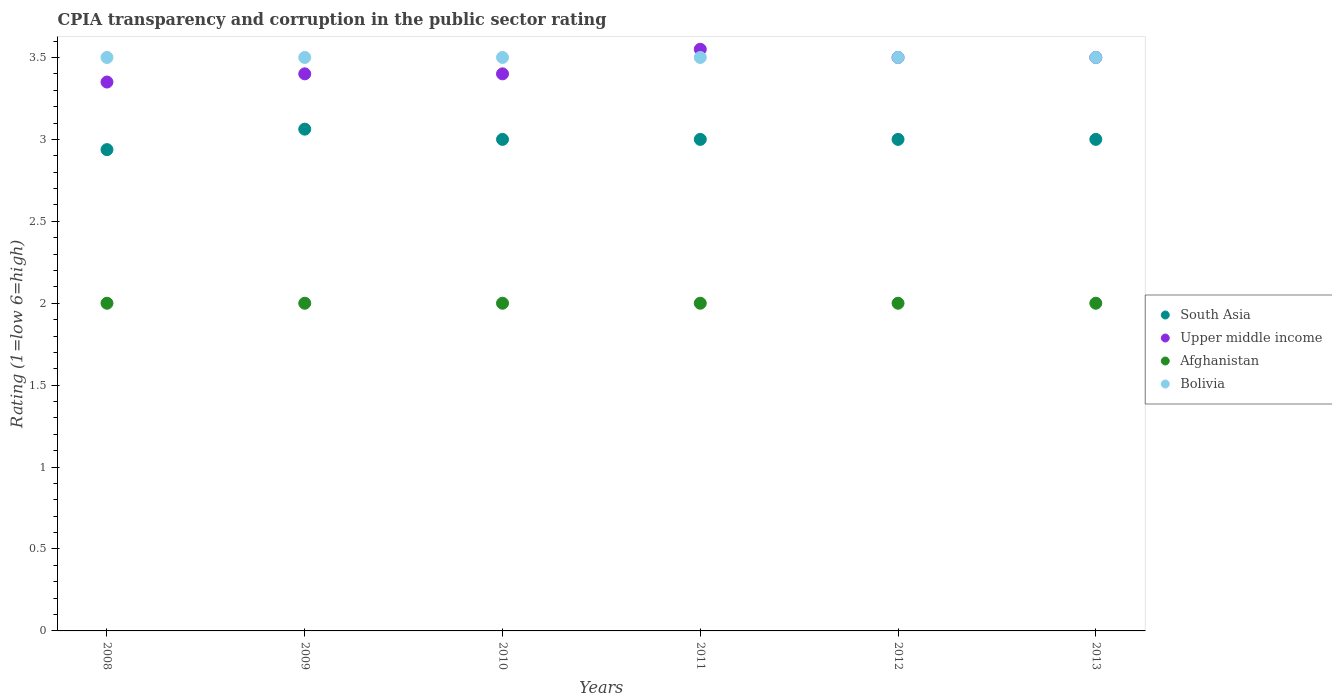How many different coloured dotlines are there?
Offer a very short reply. 4. What is the CPIA rating in South Asia in 2008?
Provide a short and direct response. 2.94. In which year was the CPIA rating in Afghanistan minimum?
Your answer should be very brief. 2008. What is the total CPIA rating in South Asia in the graph?
Provide a short and direct response. 18. What is the difference between the CPIA rating in South Asia in 2009 and that in 2011?
Your answer should be very brief. 0.06. What is the average CPIA rating in Afghanistan per year?
Provide a short and direct response. 2. In the year 2013, what is the difference between the CPIA rating in Afghanistan and CPIA rating in Upper middle income?
Your answer should be very brief. -1.5. In how many years, is the CPIA rating in Bolivia greater than 1.7?
Make the answer very short. 6. What is the ratio of the CPIA rating in South Asia in 2009 to that in 2011?
Make the answer very short. 1.02. Is the CPIA rating in Upper middle income in 2011 less than that in 2012?
Make the answer very short. No. What is the difference between the highest and the second highest CPIA rating in South Asia?
Ensure brevity in your answer.  0.06. In how many years, is the CPIA rating in Afghanistan greater than the average CPIA rating in Afghanistan taken over all years?
Your answer should be compact. 0. Does the CPIA rating in Bolivia monotonically increase over the years?
Offer a very short reply. No. Is the CPIA rating in South Asia strictly less than the CPIA rating in Bolivia over the years?
Give a very brief answer. Yes. What is the difference between two consecutive major ticks on the Y-axis?
Make the answer very short. 0.5. Does the graph contain grids?
Your answer should be very brief. No. How many legend labels are there?
Your answer should be very brief. 4. How are the legend labels stacked?
Provide a succinct answer. Vertical. What is the title of the graph?
Make the answer very short. CPIA transparency and corruption in the public sector rating. Does "Tunisia" appear as one of the legend labels in the graph?
Give a very brief answer. No. What is the Rating (1=low 6=high) of South Asia in 2008?
Provide a short and direct response. 2.94. What is the Rating (1=low 6=high) in Upper middle income in 2008?
Provide a succinct answer. 3.35. What is the Rating (1=low 6=high) in Bolivia in 2008?
Your answer should be very brief. 3.5. What is the Rating (1=low 6=high) in South Asia in 2009?
Keep it short and to the point. 3.06. What is the Rating (1=low 6=high) in Bolivia in 2009?
Offer a terse response. 3.5. What is the Rating (1=low 6=high) in Afghanistan in 2010?
Provide a short and direct response. 2. What is the Rating (1=low 6=high) in Upper middle income in 2011?
Provide a succinct answer. 3.55. What is the Rating (1=low 6=high) of Afghanistan in 2011?
Make the answer very short. 2. What is the Rating (1=low 6=high) in South Asia in 2012?
Make the answer very short. 3. What is the Rating (1=low 6=high) in South Asia in 2013?
Provide a short and direct response. 3. What is the Rating (1=low 6=high) in Upper middle income in 2013?
Your answer should be compact. 3.5. Across all years, what is the maximum Rating (1=low 6=high) in South Asia?
Provide a short and direct response. 3.06. Across all years, what is the maximum Rating (1=low 6=high) in Upper middle income?
Make the answer very short. 3.55. Across all years, what is the maximum Rating (1=low 6=high) in Bolivia?
Keep it short and to the point. 3.5. Across all years, what is the minimum Rating (1=low 6=high) in South Asia?
Provide a succinct answer. 2.94. Across all years, what is the minimum Rating (1=low 6=high) in Upper middle income?
Offer a terse response. 3.35. Across all years, what is the minimum Rating (1=low 6=high) of Afghanistan?
Provide a succinct answer. 2. What is the total Rating (1=low 6=high) in South Asia in the graph?
Provide a short and direct response. 18. What is the total Rating (1=low 6=high) of Upper middle income in the graph?
Your answer should be compact. 20.7. What is the difference between the Rating (1=low 6=high) in South Asia in 2008 and that in 2009?
Your answer should be compact. -0.12. What is the difference between the Rating (1=low 6=high) in Upper middle income in 2008 and that in 2009?
Your answer should be very brief. -0.05. What is the difference between the Rating (1=low 6=high) in Afghanistan in 2008 and that in 2009?
Offer a terse response. 0. What is the difference between the Rating (1=low 6=high) in Bolivia in 2008 and that in 2009?
Your response must be concise. 0. What is the difference between the Rating (1=low 6=high) of South Asia in 2008 and that in 2010?
Your answer should be compact. -0.06. What is the difference between the Rating (1=low 6=high) in Upper middle income in 2008 and that in 2010?
Your answer should be compact. -0.05. What is the difference between the Rating (1=low 6=high) of Afghanistan in 2008 and that in 2010?
Your answer should be compact. 0. What is the difference between the Rating (1=low 6=high) of South Asia in 2008 and that in 2011?
Give a very brief answer. -0.06. What is the difference between the Rating (1=low 6=high) of Upper middle income in 2008 and that in 2011?
Your answer should be compact. -0.2. What is the difference between the Rating (1=low 6=high) of South Asia in 2008 and that in 2012?
Make the answer very short. -0.06. What is the difference between the Rating (1=low 6=high) of Upper middle income in 2008 and that in 2012?
Make the answer very short. -0.15. What is the difference between the Rating (1=low 6=high) in South Asia in 2008 and that in 2013?
Provide a succinct answer. -0.06. What is the difference between the Rating (1=low 6=high) of Afghanistan in 2008 and that in 2013?
Offer a very short reply. 0. What is the difference between the Rating (1=low 6=high) of Bolivia in 2008 and that in 2013?
Your answer should be very brief. 0. What is the difference between the Rating (1=low 6=high) in South Asia in 2009 and that in 2010?
Keep it short and to the point. 0.06. What is the difference between the Rating (1=low 6=high) of Upper middle income in 2009 and that in 2010?
Make the answer very short. 0. What is the difference between the Rating (1=low 6=high) of Afghanistan in 2009 and that in 2010?
Make the answer very short. 0. What is the difference between the Rating (1=low 6=high) in South Asia in 2009 and that in 2011?
Ensure brevity in your answer.  0.06. What is the difference between the Rating (1=low 6=high) in Upper middle income in 2009 and that in 2011?
Give a very brief answer. -0.15. What is the difference between the Rating (1=low 6=high) in Afghanistan in 2009 and that in 2011?
Offer a very short reply. 0. What is the difference between the Rating (1=low 6=high) of Bolivia in 2009 and that in 2011?
Provide a succinct answer. 0. What is the difference between the Rating (1=low 6=high) of South Asia in 2009 and that in 2012?
Provide a succinct answer. 0.06. What is the difference between the Rating (1=low 6=high) of Bolivia in 2009 and that in 2012?
Make the answer very short. 0. What is the difference between the Rating (1=low 6=high) of South Asia in 2009 and that in 2013?
Provide a succinct answer. 0.06. What is the difference between the Rating (1=low 6=high) in Upper middle income in 2009 and that in 2013?
Your answer should be compact. -0.1. What is the difference between the Rating (1=low 6=high) of Bolivia in 2009 and that in 2013?
Offer a terse response. 0. What is the difference between the Rating (1=low 6=high) of Upper middle income in 2010 and that in 2011?
Keep it short and to the point. -0.15. What is the difference between the Rating (1=low 6=high) in Afghanistan in 2010 and that in 2011?
Your response must be concise. 0. What is the difference between the Rating (1=low 6=high) of Upper middle income in 2010 and that in 2012?
Provide a short and direct response. -0.1. What is the difference between the Rating (1=low 6=high) in Afghanistan in 2010 and that in 2012?
Offer a very short reply. 0. What is the difference between the Rating (1=low 6=high) in Bolivia in 2010 and that in 2012?
Your answer should be compact. 0. What is the difference between the Rating (1=low 6=high) of Afghanistan in 2010 and that in 2013?
Your answer should be very brief. 0. What is the difference between the Rating (1=low 6=high) of Bolivia in 2010 and that in 2013?
Offer a terse response. 0. What is the difference between the Rating (1=low 6=high) in Upper middle income in 2011 and that in 2012?
Provide a short and direct response. 0.05. What is the difference between the Rating (1=low 6=high) in Afghanistan in 2011 and that in 2012?
Your answer should be very brief. 0. What is the difference between the Rating (1=low 6=high) of South Asia in 2011 and that in 2013?
Provide a succinct answer. 0. What is the difference between the Rating (1=low 6=high) in Afghanistan in 2012 and that in 2013?
Provide a short and direct response. 0. What is the difference between the Rating (1=low 6=high) in Bolivia in 2012 and that in 2013?
Ensure brevity in your answer.  0. What is the difference between the Rating (1=low 6=high) of South Asia in 2008 and the Rating (1=low 6=high) of Upper middle income in 2009?
Keep it short and to the point. -0.46. What is the difference between the Rating (1=low 6=high) in South Asia in 2008 and the Rating (1=low 6=high) in Bolivia in 2009?
Your answer should be very brief. -0.56. What is the difference between the Rating (1=low 6=high) of Upper middle income in 2008 and the Rating (1=low 6=high) of Afghanistan in 2009?
Give a very brief answer. 1.35. What is the difference between the Rating (1=low 6=high) of Upper middle income in 2008 and the Rating (1=low 6=high) of Bolivia in 2009?
Ensure brevity in your answer.  -0.15. What is the difference between the Rating (1=low 6=high) in Afghanistan in 2008 and the Rating (1=low 6=high) in Bolivia in 2009?
Provide a short and direct response. -1.5. What is the difference between the Rating (1=low 6=high) in South Asia in 2008 and the Rating (1=low 6=high) in Upper middle income in 2010?
Make the answer very short. -0.46. What is the difference between the Rating (1=low 6=high) of South Asia in 2008 and the Rating (1=low 6=high) of Bolivia in 2010?
Give a very brief answer. -0.56. What is the difference between the Rating (1=low 6=high) in Upper middle income in 2008 and the Rating (1=low 6=high) in Afghanistan in 2010?
Your answer should be very brief. 1.35. What is the difference between the Rating (1=low 6=high) in South Asia in 2008 and the Rating (1=low 6=high) in Upper middle income in 2011?
Make the answer very short. -0.61. What is the difference between the Rating (1=low 6=high) of South Asia in 2008 and the Rating (1=low 6=high) of Afghanistan in 2011?
Ensure brevity in your answer.  0.94. What is the difference between the Rating (1=low 6=high) of South Asia in 2008 and the Rating (1=low 6=high) of Bolivia in 2011?
Provide a short and direct response. -0.56. What is the difference between the Rating (1=low 6=high) of Upper middle income in 2008 and the Rating (1=low 6=high) of Afghanistan in 2011?
Provide a short and direct response. 1.35. What is the difference between the Rating (1=low 6=high) in South Asia in 2008 and the Rating (1=low 6=high) in Upper middle income in 2012?
Offer a very short reply. -0.56. What is the difference between the Rating (1=low 6=high) in South Asia in 2008 and the Rating (1=low 6=high) in Afghanistan in 2012?
Your answer should be very brief. 0.94. What is the difference between the Rating (1=low 6=high) of South Asia in 2008 and the Rating (1=low 6=high) of Bolivia in 2012?
Your answer should be compact. -0.56. What is the difference between the Rating (1=low 6=high) of Upper middle income in 2008 and the Rating (1=low 6=high) of Afghanistan in 2012?
Provide a succinct answer. 1.35. What is the difference between the Rating (1=low 6=high) of South Asia in 2008 and the Rating (1=low 6=high) of Upper middle income in 2013?
Your answer should be very brief. -0.56. What is the difference between the Rating (1=low 6=high) in South Asia in 2008 and the Rating (1=low 6=high) in Afghanistan in 2013?
Make the answer very short. 0.94. What is the difference between the Rating (1=low 6=high) of South Asia in 2008 and the Rating (1=low 6=high) of Bolivia in 2013?
Provide a short and direct response. -0.56. What is the difference between the Rating (1=low 6=high) in Upper middle income in 2008 and the Rating (1=low 6=high) in Afghanistan in 2013?
Keep it short and to the point. 1.35. What is the difference between the Rating (1=low 6=high) in Afghanistan in 2008 and the Rating (1=low 6=high) in Bolivia in 2013?
Give a very brief answer. -1.5. What is the difference between the Rating (1=low 6=high) of South Asia in 2009 and the Rating (1=low 6=high) of Upper middle income in 2010?
Your answer should be compact. -0.34. What is the difference between the Rating (1=low 6=high) in South Asia in 2009 and the Rating (1=low 6=high) in Afghanistan in 2010?
Make the answer very short. 1.06. What is the difference between the Rating (1=low 6=high) of South Asia in 2009 and the Rating (1=low 6=high) of Bolivia in 2010?
Make the answer very short. -0.44. What is the difference between the Rating (1=low 6=high) of Afghanistan in 2009 and the Rating (1=low 6=high) of Bolivia in 2010?
Your answer should be very brief. -1.5. What is the difference between the Rating (1=low 6=high) of South Asia in 2009 and the Rating (1=low 6=high) of Upper middle income in 2011?
Your answer should be compact. -0.49. What is the difference between the Rating (1=low 6=high) of South Asia in 2009 and the Rating (1=low 6=high) of Bolivia in 2011?
Your response must be concise. -0.44. What is the difference between the Rating (1=low 6=high) in Upper middle income in 2009 and the Rating (1=low 6=high) in Afghanistan in 2011?
Your answer should be very brief. 1.4. What is the difference between the Rating (1=low 6=high) in South Asia in 2009 and the Rating (1=low 6=high) in Upper middle income in 2012?
Provide a succinct answer. -0.44. What is the difference between the Rating (1=low 6=high) of South Asia in 2009 and the Rating (1=low 6=high) of Bolivia in 2012?
Provide a short and direct response. -0.44. What is the difference between the Rating (1=low 6=high) in Upper middle income in 2009 and the Rating (1=low 6=high) in Bolivia in 2012?
Ensure brevity in your answer.  -0.1. What is the difference between the Rating (1=low 6=high) in Afghanistan in 2009 and the Rating (1=low 6=high) in Bolivia in 2012?
Your answer should be very brief. -1.5. What is the difference between the Rating (1=low 6=high) of South Asia in 2009 and the Rating (1=low 6=high) of Upper middle income in 2013?
Offer a terse response. -0.44. What is the difference between the Rating (1=low 6=high) in South Asia in 2009 and the Rating (1=low 6=high) in Afghanistan in 2013?
Offer a terse response. 1.06. What is the difference between the Rating (1=low 6=high) of South Asia in 2009 and the Rating (1=low 6=high) of Bolivia in 2013?
Give a very brief answer. -0.44. What is the difference between the Rating (1=low 6=high) of Upper middle income in 2009 and the Rating (1=low 6=high) of Bolivia in 2013?
Your answer should be compact. -0.1. What is the difference between the Rating (1=low 6=high) in South Asia in 2010 and the Rating (1=low 6=high) in Upper middle income in 2011?
Your answer should be very brief. -0.55. What is the difference between the Rating (1=low 6=high) of South Asia in 2010 and the Rating (1=low 6=high) of Afghanistan in 2011?
Your answer should be compact. 1. What is the difference between the Rating (1=low 6=high) in Upper middle income in 2010 and the Rating (1=low 6=high) in Afghanistan in 2011?
Your answer should be compact. 1.4. What is the difference between the Rating (1=low 6=high) of Upper middle income in 2010 and the Rating (1=low 6=high) of Bolivia in 2011?
Offer a very short reply. -0.1. What is the difference between the Rating (1=low 6=high) of Afghanistan in 2010 and the Rating (1=low 6=high) of Bolivia in 2011?
Offer a very short reply. -1.5. What is the difference between the Rating (1=low 6=high) of South Asia in 2010 and the Rating (1=low 6=high) of Upper middle income in 2012?
Give a very brief answer. -0.5. What is the difference between the Rating (1=low 6=high) in South Asia in 2010 and the Rating (1=low 6=high) in Afghanistan in 2012?
Provide a short and direct response. 1. What is the difference between the Rating (1=low 6=high) in South Asia in 2010 and the Rating (1=low 6=high) in Bolivia in 2012?
Ensure brevity in your answer.  -0.5. What is the difference between the Rating (1=low 6=high) of Upper middle income in 2010 and the Rating (1=low 6=high) of Afghanistan in 2012?
Provide a short and direct response. 1.4. What is the difference between the Rating (1=low 6=high) in South Asia in 2010 and the Rating (1=low 6=high) in Upper middle income in 2013?
Your response must be concise. -0.5. What is the difference between the Rating (1=low 6=high) of South Asia in 2010 and the Rating (1=low 6=high) of Afghanistan in 2013?
Keep it short and to the point. 1. What is the difference between the Rating (1=low 6=high) of South Asia in 2010 and the Rating (1=low 6=high) of Bolivia in 2013?
Your answer should be compact. -0.5. What is the difference between the Rating (1=low 6=high) of Upper middle income in 2010 and the Rating (1=low 6=high) of Afghanistan in 2013?
Keep it short and to the point. 1.4. What is the difference between the Rating (1=low 6=high) in Upper middle income in 2010 and the Rating (1=low 6=high) in Bolivia in 2013?
Your response must be concise. -0.1. What is the difference between the Rating (1=low 6=high) of South Asia in 2011 and the Rating (1=low 6=high) of Bolivia in 2012?
Your answer should be compact. -0.5. What is the difference between the Rating (1=low 6=high) of Upper middle income in 2011 and the Rating (1=low 6=high) of Afghanistan in 2012?
Keep it short and to the point. 1.55. What is the difference between the Rating (1=low 6=high) of Afghanistan in 2011 and the Rating (1=low 6=high) of Bolivia in 2012?
Make the answer very short. -1.5. What is the difference between the Rating (1=low 6=high) of South Asia in 2011 and the Rating (1=low 6=high) of Upper middle income in 2013?
Offer a very short reply. -0.5. What is the difference between the Rating (1=low 6=high) in South Asia in 2011 and the Rating (1=low 6=high) in Afghanistan in 2013?
Ensure brevity in your answer.  1. What is the difference between the Rating (1=low 6=high) in Upper middle income in 2011 and the Rating (1=low 6=high) in Afghanistan in 2013?
Offer a very short reply. 1.55. What is the difference between the Rating (1=low 6=high) of South Asia in 2012 and the Rating (1=low 6=high) of Upper middle income in 2013?
Keep it short and to the point. -0.5. What is the difference between the Rating (1=low 6=high) in South Asia in 2012 and the Rating (1=low 6=high) in Afghanistan in 2013?
Give a very brief answer. 1. What is the difference between the Rating (1=low 6=high) of Upper middle income in 2012 and the Rating (1=low 6=high) of Afghanistan in 2013?
Make the answer very short. 1.5. What is the average Rating (1=low 6=high) of South Asia per year?
Make the answer very short. 3. What is the average Rating (1=low 6=high) in Upper middle income per year?
Your answer should be very brief. 3.45. What is the average Rating (1=low 6=high) in Afghanistan per year?
Offer a terse response. 2. What is the average Rating (1=low 6=high) in Bolivia per year?
Keep it short and to the point. 3.5. In the year 2008, what is the difference between the Rating (1=low 6=high) in South Asia and Rating (1=low 6=high) in Upper middle income?
Offer a very short reply. -0.41. In the year 2008, what is the difference between the Rating (1=low 6=high) of South Asia and Rating (1=low 6=high) of Bolivia?
Give a very brief answer. -0.56. In the year 2008, what is the difference between the Rating (1=low 6=high) in Upper middle income and Rating (1=low 6=high) in Afghanistan?
Your response must be concise. 1.35. In the year 2009, what is the difference between the Rating (1=low 6=high) in South Asia and Rating (1=low 6=high) in Upper middle income?
Ensure brevity in your answer.  -0.34. In the year 2009, what is the difference between the Rating (1=low 6=high) in South Asia and Rating (1=low 6=high) in Afghanistan?
Keep it short and to the point. 1.06. In the year 2009, what is the difference between the Rating (1=low 6=high) of South Asia and Rating (1=low 6=high) of Bolivia?
Ensure brevity in your answer.  -0.44. In the year 2009, what is the difference between the Rating (1=low 6=high) in Upper middle income and Rating (1=low 6=high) in Afghanistan?
Your answer should be compact. 1.4. In the year 2010, what is the difference between the Rating (1=low 6=high) of South Asia and Rating (1=low 6=high) of Upper middle income?
Your response must be concise. -0.4. In the year 2010, what is the difference between the Rating (1=low 6=high) in South Asia and Rating (1=low 6=high) in Bolivia?
Give a very brief answer. -0.5. In the year 2011, what is the difference between the Rating (1=low 6=high) of South Asia and Rating (1=low 6=high) of Upper middle income?
Offer a terse response. -0.55. In the year 2011, what is the difference between the Rating (1=low 6=high) of South Asia and Rating (1=low 6=high) of Afghanistan?
Your response must be concise. 1. In the year 2011, what is the difference between the Rating (1=low 6=high) of Upper middle income and Rating (1=low 6=high) of Afghanistan?
Make the answer very short. 1.55. In the year 2011, what is the difference between the Rating (1=low 6=high) of Upper middle income and Rating (1=low 6=high) of Bolivia?
Your answer should be compact. 0.05. In the year 2012, what is the difference between the Rating (1=low 6=high) in South Asia and Rating (1=low 6=high) in Upper middle income?
Offer a very short reply. -0.5. In the year 2012, what is the difference between the Rating (1=low 6=high) of South Asia and Rating (1=low 6=high) of Bolivia?
Give a very brief answer. -0.5. In the year 2012, what is the difference between the Rating (1=low 6=high) in Upper middle income and Rating (1=low 6=high) in Afghanistan?
Make the answer very short. 1.5. In the year 2013, what is the difference between the Rating (1=low 6=high) in South Asia and Rating (1=low 6=high) in Upper middle income?
Ensure brevity in your answer.  -0.5. In the year 2013, what is the difference between the Rating (1=low 6=high) of South Asia and Rating (1=low 6=high) of Bolivia?
Give a very brief answer. -0.5. In the year 2013, what is the difference between the Rating (1=low 6=high) of Upper middle income and Rating (1=low 6=high) of Afghanistan?
Keep it short and to the point. 1.5. What is the ratio of the Rating (1=low 6=high) in South Asia in 2008 to that in 2009?
Provide a succinct answer. 0.96. What is the ratio of the Rating (1=low 6=high) of Bolivia in 2008 to that in 2009?
Keep it short and to the point. 1. What is the ratio of the Rating (1=low 6=high) of South Asia in 2008 to that in 2010?
Make the answer very short. 0.98. What is the ratio of the Rating (1=low 6=high) in Bolivia in 2008 to that in 2010?
Make the answer very short. 1. What is the ratio of the Rating (1=low 6=high) of South Asia in 2008 to that in 2011?
Provide a succinct answer. 0.98. What is the ratio of the Rating (1=low 6=high) of Upper middle income in 2008 to that in 2011?
Your answer should be compact. 0.94. What is the ratio of the Rating (1=low 6=high) of Bolivia in 2008 to that in 2011?
Provide a succinct answer. 1. What is the ratio of the Rating (1=low 6=high) in South Asia in 2008 to that in 2012?
Offer a terse response. 0.98. What is the ratio of the Rating (1=low 6=high) in Upper middle income in 2008 to that in 2012?
Offer a very short reply. 0.96. What is the ratio of the Rating (1=low 6=high) in Afghanistan in 2008 to that in 2012?
Your response must be concise. 1. What is the ratio of the Rating (1=low 6=high) of South Asia in 2008 to that in 2013?
Make the answer very short. 0.98. What is the ratio of the Rating (1=low 6=high) of Upper middle income in 2008 to that in 2013?
Offer a very short reply. 0.96. What is the ratio of the Rating (1=low 6=high) in Afghanistan in 2008 to that in 2013?
Provide a succinct answer. 1. What is the ratio of the Rating (1=low 6=high) in South Asia in 2009 to that in 2010?
Your response must be concise. 1.02. What is the ratio of the Rating (1=low 6=high) in Upper middle income in 2009 to that in 2010?
Provide a short and direct response. 1. What is the ratio of the Rating (1=low 6=high) of Afghanistan in 2009 to that in 2010?
Give a very brief answer. 1. What is the ratio of the Rating (1=low 6=high) in Bolivia in 2009 to that in 2010?
Give a very brief answer. 1. What is the ratio of the Rating (1=low 6=high) in South Asia in 2009 to that in 2011?
Ensure brevity in your answer.  1.02. What is the ratio of the Rating (1=low 6=high) in Upper middle income in 2009 to that in 2011?
Make the answer very short. 0.96. What is the ratio of the Rating (1=low 6=high) in Bolivia in 2009 to that in 2011?
Give a very brief answer. 1. What is the ratio of the Rating (1=low 6=high) of South Asia in 2009 to that in 2012?
Ensure brevity in your answer.  1.02. What is the ratio of the Rating (1=low 6=high) of Upper middle income in 2009 to that in 2012?
Keep it short and to the point. 0.97. What is the ratio of the Rating (1=low 6=high) of Afghanistan in 2009 to that in 2012?
Keep it short and to the point. 1. What is the ratio of the Rating (1=low 6=high) of Bolivia in 2009 to that in 2012?
Offer a very short reply. 1. What is the ratio of the Rating (1=low 6=high) of South Asia in 2009 to that in 2013?
Offer a very short reply. 1.02. What is the ratio of the Rating (1=low 6=high) in Upper middle income in 2009 to that in 2013?
Keep it short and to the point. 0.97. What is the ratio of the Rating (1=low 6=high) of South Asia in 2010 to that in 2011?
Offer a terse response. 1. What is the ratio of the Rating (1=low 6=high) of Upper middle income in 2010 to that in 2011?
Provide a succinct answer. 0.96. What is the ratio of the Rating (1=low 6=high) in Afghanistan in 2010 to that in 2011?
Provide a succinct answer. 1. What is the ratio of the Rating (1=low 6=high) of Upper middle income in 2010 to that in 2012?
Offer a terse response. 0.97. What is the ratio of the Rating (1=low 6=high) of Afghanistan in 2010 to that in 2012?
Keep it short and to the point. 1. What is the ratio of the Rating (1=low 6=high) of Bolivia in 2010 to that in 2012?
Your answer should be compact. 1. What is the ratio of the Rating (1=low 6=high) of Upper middle income in 2010 to that in 2013?
Ensure brevity in your answer.  0.97. What is the ratio of the Rating (1=low 6=high) in Afghanistan in 2010 to that in 2013?
Provide a succinct answer. 1. What is the ratio of the Rating (1=low 6=high) of South Asia in 2011 to that in 2012?
Your answer should be very brief. 1. What is the ratio of the Rating (1=low 6=high) in Upper middle income in 2011 to that in 2012?
Your answer should be compact. 1.01. What is the ratio of the Rating (1=low 6=high) of Bolivia in 2011 to that in 2012?
Ensure brevity in your answer.  1. What is the ratio of the Rating (1=low 6=high) in South Asia in 2011 to that in 2013?
Your answer should be very brief. 1. What is the ratio of the Rating (1=low 6=high) of Upper middle income in 2011 to that in 2013?
Your answer should be very brief. 1.01. What is the ratio of the Rating (1=low 6=high) in Bolivia in 2012 to that in 2013?
Give a very brief answer. 1. What is the difference between the highest and the second highest Rating (1=low 6=high) in South Asia?
Provide a short and direct response. 0.06. What is the difference between the highest and the second highest Rating (1=low 6=high) in Afghanistan?
Keep it short and to the point. 0. What is the difference between the highest and the second highest Rating (1=low 6=high) in Bolivia?
Your response must be concise. 0. What is the difference between the highest and the lowest Rating (1=low 6=high) in Upper middle income?
Your response must be concise. 0.2. What is the difference between the highest and the lowest Rating (1=low 6=high) of Bolivia?
Give a very brief answer. 0. 